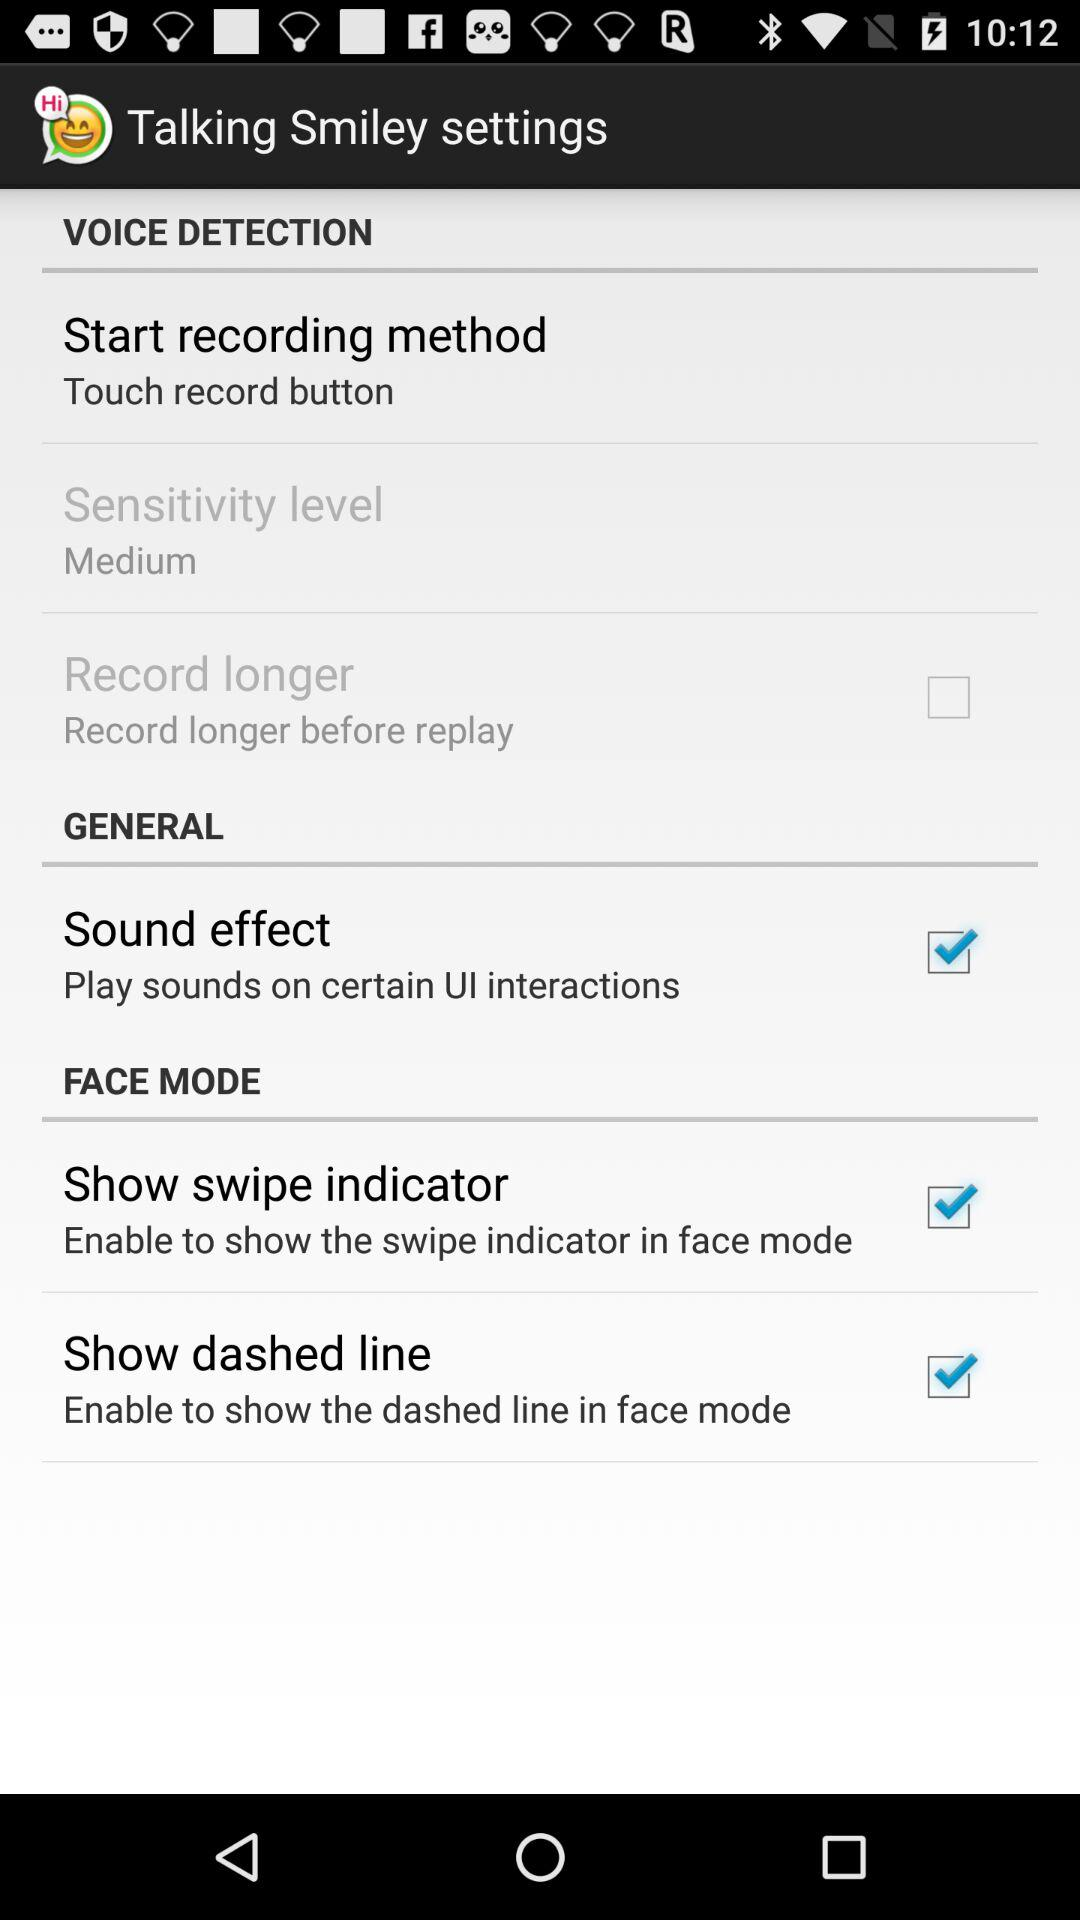What's the sensitivity level? The sensitivity level is medium. 